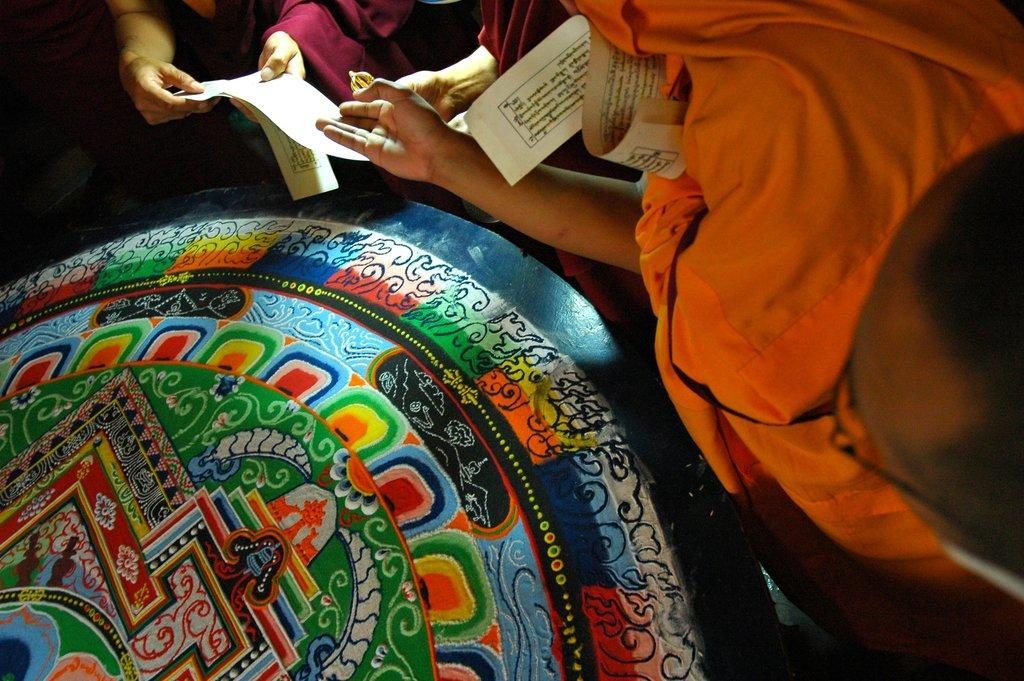What object can be found in the bottom left corner of the image? There is a table in the bottom left corner of the image. What are the people in the image doing? The people are standing at the top of the image and holding papers. What type of wound can be seen on the person's arm in the image? There is no wound visible on anyone's arm in the image. Can you see any matches or hoses in the image? No, there are no matches or hoses present in the image. 